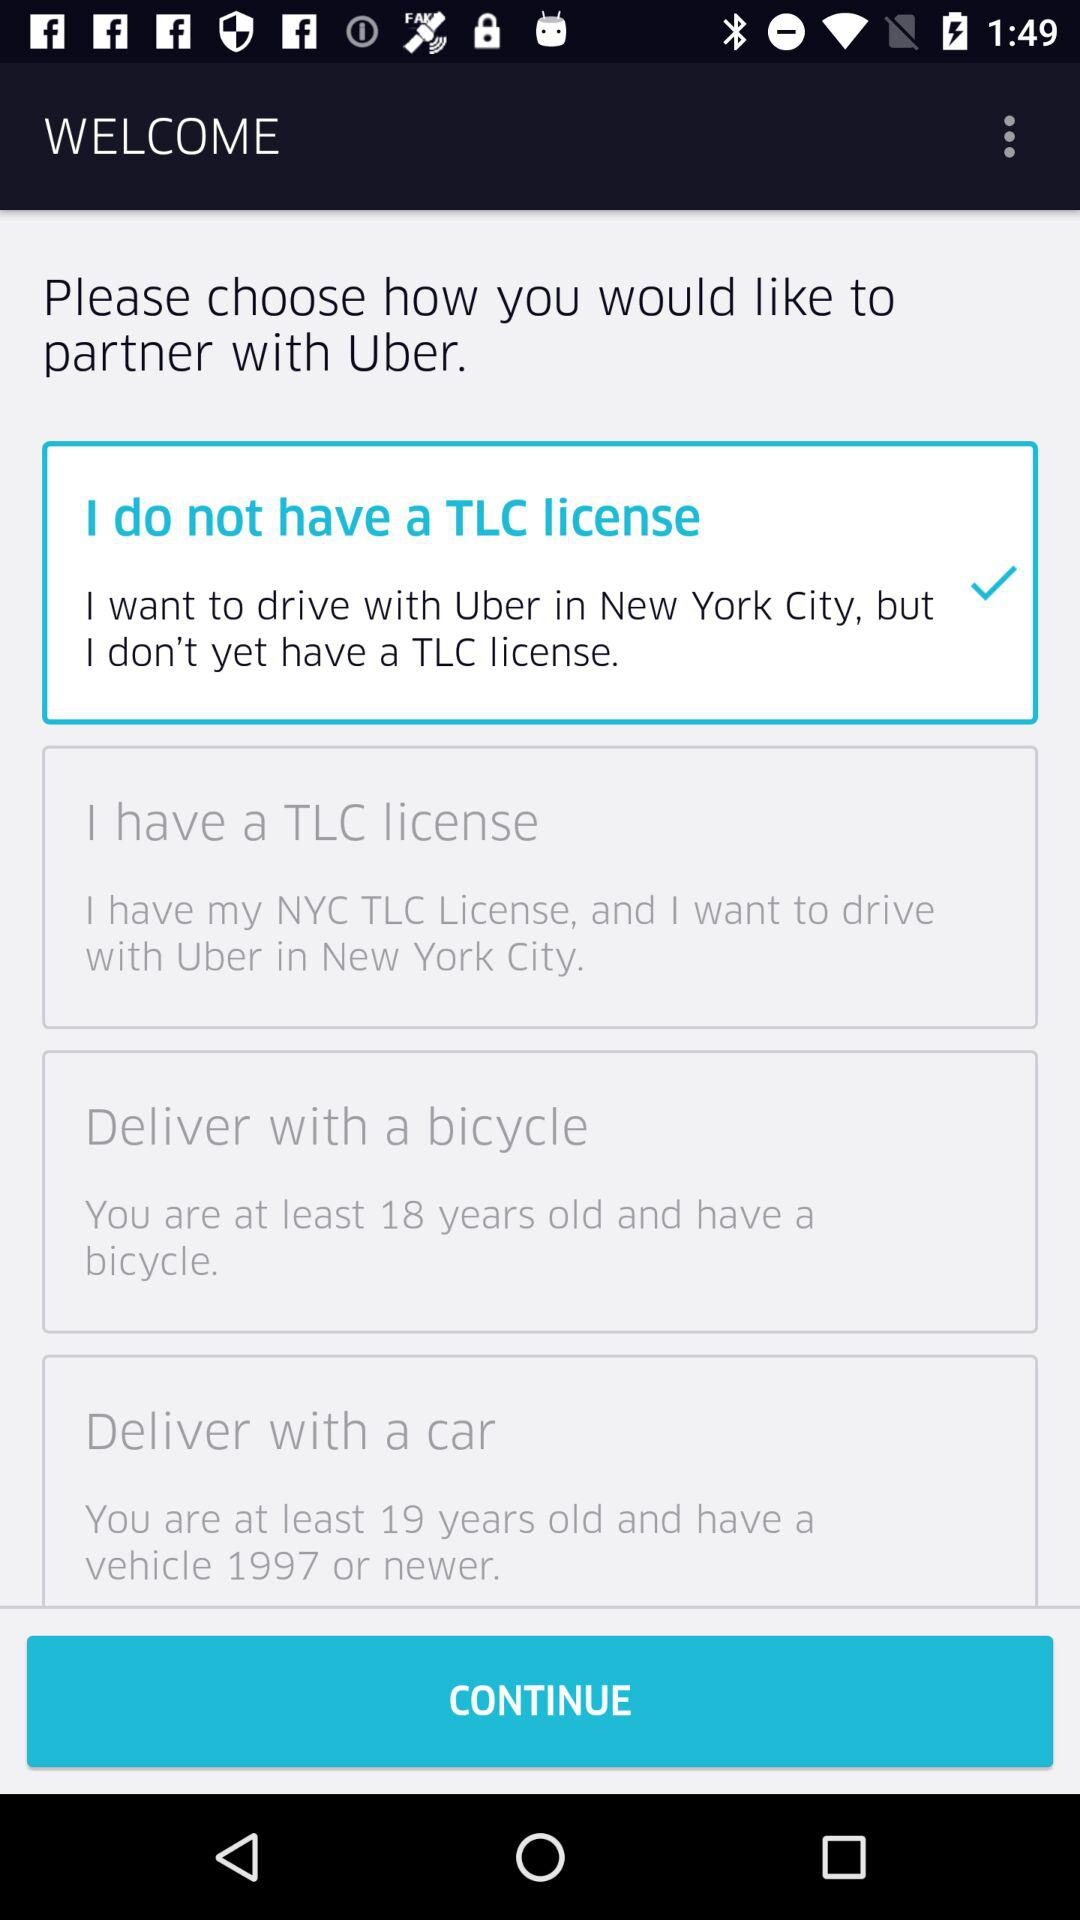How many items are there that require a license?
Answer the question using a single word or phrase. 2 